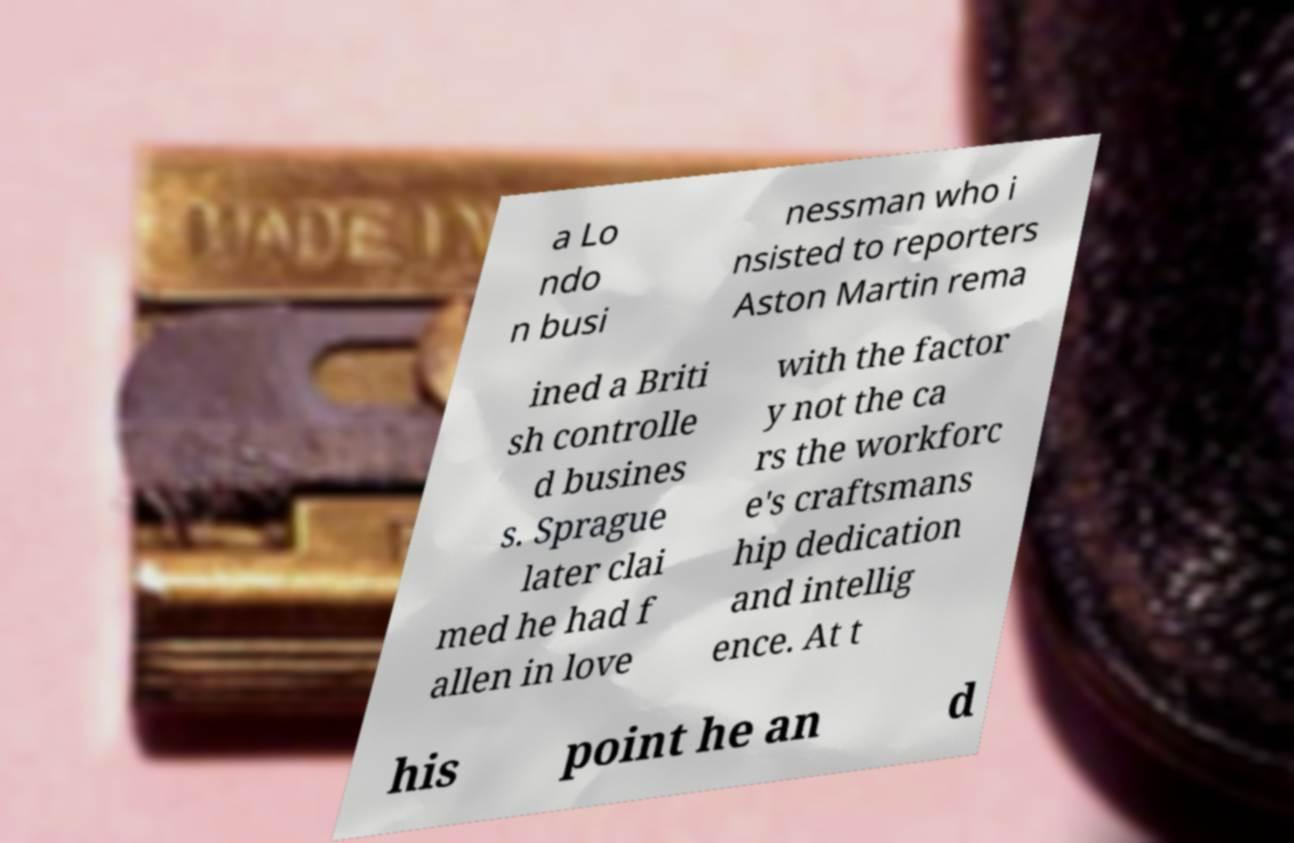Could you extract and type out the text from this image? a Lo ndo n busi nessman who i nsisted to reporters Aston Martin rema ined a Briti sh controlle d busines s. Sprague later clai med he had f allen in love with the factor y not the ca rs the workforc e's craftsmans hip dedication and intellig ence. At t his point he an d 